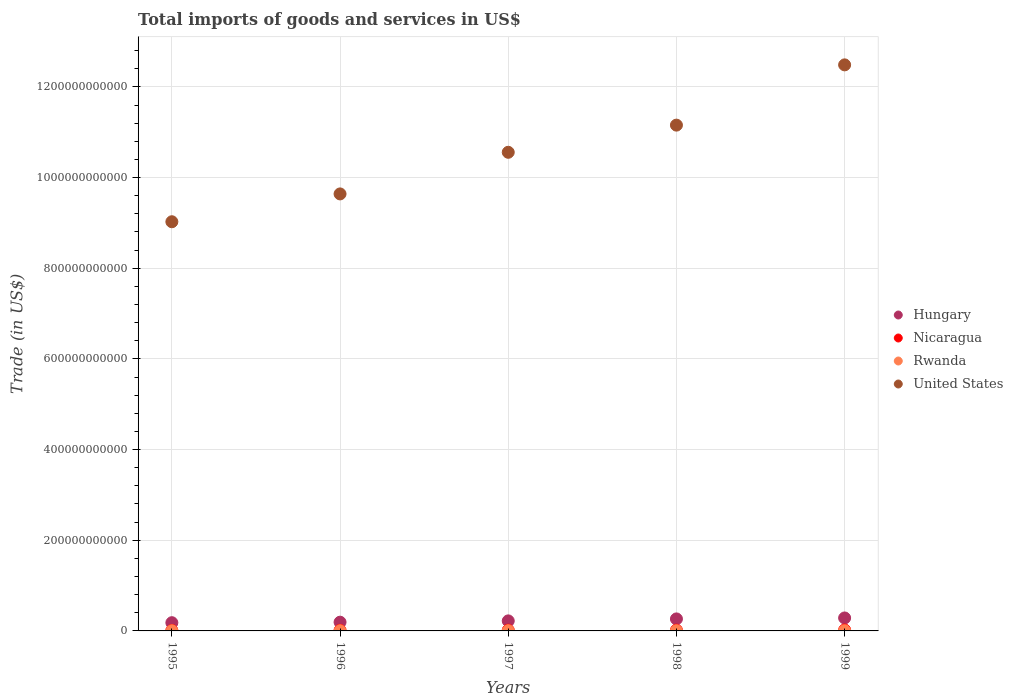How many different coloured dotlines are there?
Provide a short and direct response. 4. Is the number of dotlines equal to the number of legend labels?
Your answer should be very brief. Yes. What is the total imports of goods and services in Rwanda in 1997?
Provide a succinct answer. 4.75e+08. Across all years, what is the maximum total imports of goods and services in Hungary?
Your answer should be compact. 2.86e+1. Across all years, what is the minimum total imports of goods and services in Hungary?
Your answer should be compact. 1.81e+1. In which year was the total imports of goods and services in Nicaragua maximum?
Your answer should be very brief. 1999. What is the total total imports of goods and services in Rwanda in the graph?
Ensure brevity in your answer.  2.08e+09. What is the difference between the total imports of goods and services in United States in 1995 and that in 1998?
Offer a terse response. -2.13e+11. What is the difference between the total imports of goods and services in Nicaragua in 1997 and the total imports of goods and services in United States in 1996?
Offer a terse response. -9.62e+11. What is the average total imports of goods and services in United States per year?
Offer a very short reply. 1.06e+12. In the year 1996, what is the difference between the total imports of goods and services in Nicaragua and total imports of goods and services in Hungary?
Keep it short and to the point. -1.79e+1. In how many years, is the total imports of goods and services in Nicaragua greater than 600000000000 US$?
Offer a very short reply. 0. What is the ratio of the total imports of goods and services in Rwanda in 1996 to that in 1997?
Offer a terse response. 0.76. Is the difference between the total imports of goods and services in Nicaragua in 1998 and 1999 greater than the difference between the total imports of goods and services in Hungary in 1998 and 1999?
Keep it short and to the point. Yes. What is the difference between the highest and the second highest total imports of goods and services in Rwanda?
Provide a short and direct response. 1.36e+07. What is the difference between the highest and the lowest total imports of goods and services in Nicaragua?
Give a very brief answer. 9.80e+08. Is the sum of the total imports of goods and services in United States in 1996 and 1997 greater than the maximum total imports of goods and services in Hungary across all years?
Give a very brief answer. Yes. Is it the case that in every year, the sum of the total imports of goods and services in United States and total imports of goods and services in Rwanda  is greater than the total imports of goods and services in Nicaragua?
Make the answer very short. Yes. Is the total imports of goods and services in Rwanda strictly greater than the total imports of goods and services in Hungary over the years?
Give a very brief answer. No. Is the total imports of goods and services in Rwanda strictly less than the total imports of goods and services in United States over the years?
Give a very brief answer. Yes. How many years are there in the graph?
Offer a terse response. 5. What is the difference between two consecutive major ticks on the Y-axis?
Provide a short and direct response. 2.00e+11. Are the values on the major ticks of Y-axis written in scientific E-notation?
Your response must be concise. No. Does the graph contain grids?
Make the answer very short. Yes. How are the legend labels stacked?
Provide a succinct answer. Vertical. What is the title of the graph?
Your answer should be compact. Total imports of goods and services in US$. Does "Sub-Saharan Africa (all income levels)" appear as one of the legend labels in the graph?
Make the answer very short. No. What is the label or title of the X-axis?
Offer a very short reply. Years. What is the label or title of the Y-axis?
Offer a very short reply. Trade (in US$). What is the Trade (in US$) of Hungary in 1995?
Make the answer very short. 1.81e+1. What is the Trade (in US$) of Nicaragua in 1995?
Your response must be concise. 1.16e+09. What is the Trade (in US$) of Rwanda in 1995?
Offer a very short reply. 3.34e+08. What is the Trade (in US$) of United States in 1995?
Give a very brief answer. 9.03e+11. What is the Trade (in US$) of Hungary in 1996?
Your response must be concise. 1.93e+1. What is the Trade (in US$) in Nicaragua in 1996?
Give a very brief answer. 1.36e+09. What is the Trade (in US$) of Rwanda in 1996?
Provide a short and direct response. 3.62e+08. What is the Trade (in US$) in United States in 1996?
Keep it short and to the point. 9.64e+11. What is the Trade (in US$) of Hungary in 1997?
Ensure brevity in your answer.  2.22e+1. What is the Trade (in US$) of Nicaragua in 1997?
Your answer should be compact. 1.69e+09. What is the Trade (in US$) of Rwanda in 1997?
Offer a very short reply. 4.75e+08. What is the Trade (in US$) of United States in 1997?
Give a very brief answer. 1.06e+12. What is the Trade (in US$) of Hungary in 1998?
Provide a succinct answer. 2.65e+1. What is the Trade (in US$) of Nicaragua in 1998?
Provide a succinct answer. 1.75e+09. What is the Trade (in US$) in Rwanda in 1998?
Make the answer very short. 4.62e+08. What is the Trade (in US$) in United States in 1998?
Keep it short and to the point. 1.12e+12. What is the Trade (in US$) in Hungary in 1999?
Make the answer very short. 2.86e+1. What is the Trade (in US$) of Nicaragua in 1999?
Give a very brief answer. 2.14e+09. What is the Trade (in US$) in Rwanda in 1999?
Your answer should be compact. 4.46e+08. What is the Trade (in US$) of United States in 1999?
Make the answer very short. 1.25e+12. Across all years, what is the maximum Trade (in US$) of Hungary?
Provide a short and direct response. 2.86e+1. Across all years, what is the maximum Trade (in US$) in Nicaragua?
Make the answer very short. 2.14e+09. Across all years, what is the maximum Trade (in US$) of Rwanda?
Offer a very short reply. 4.75e+08. Across all years, what is the maximum Trade (in US$) of United States?
Offer a terse response. 1.25e+12. Across all years, what is the minimum Trade (in US$) of Hungary?
Offer a very short reply. 1.81e+1. Across all years, what is the minimum Trade (in US$) in Nicaragua?
Keep it short and to the point. 1.16e+09. Across all years, what is the minimum Trade (in US$) in Rwanda?
Provide a succinct answer. 3.34e+08. Across all years, what is the minimum Trade (in US$) in United States?
Keep it short and to the point. 9.03e+11. What is the total Trade (in US$) in Hungary in the graph?
Your answer should be compact. 1.15e+11. What is the total Trade (in US$) in Nicaragua in the graph?
Your answer should be very brief. 8.10e+09. What is the total Trade (in US$) of Rwanda in the graph?
Provide a succinct answer. 2.08e+09. What is the total Trade (in US$) in United States in the graph?
Keep it short and to the point. 5.29e+12. What is the difference between the Trade (in US$) of Hungary in 1995 and that in 1996?
Make the answer very short. -1.13e+09. What is the difference between the Trade (in US$) of Nicaragua in 1995 and that in 1996?
Offer a very short reply. -2.06e+08. What is the difference between the Trade (in US$) of Rwanda in 1995 and that in 1996?
Ensure brevity in your answer.  -2.81e+07. What is the difference between the Trade (in US$) of United States in 1995 and that in 1996?
Offer a very short reply. -6.14e+1. What is the difference between the Trade (in US$) of Hungary in 1995 and that in 1997?
Keep it short and to the point. -4.01e+09. What is the difference between the Trade (in US$) of Nicaragua in 1995 and that in 1997?
Your answer should be compact. -5.37e+08. What is the difference between the Trade (in US$) of Rwanda in 1995 and that in 1997?
Provide a short and direct response. -1.41e+08. What is the difference between the Trade (in US$) of United States in 1995 and that in 1997?
Keep it short and to the point. -1.53e+11. What is the difference between the Trade (in US$) of Hungary in 1995 and that in 1998?
Provide a succinct answer. -8.35e+09. What is the difference between the Trade (in US$) of Nicaragua in 1995 and that in 1998?
Provide a succinct answer. -5.89e+08. What is the difference between the Trade (in US$) of Rwanda in 1995 and that in 1998?
Make the answer very short. -1.28e+08. What is the difference between the Trade (in US$) of United States in 1995 and that in 1998?
Offer a very short reply. -2.13e+11. What is the difference between the Trade (in US$) of Hungary in 1995 and that in 1999?
Keep it short and to the point. -1.05e+1. What is the difference between the Trade (in US$) in Nicaragua in 1995 and that in 1999?
Your response must be concise. -9.80e+08. What is the difference between the Trade (in US$) of Rwanda in 1995 and that in 1999?
Ensure brevity in your answer.  -1.12e+08. What is the difference between the Trade (in US$) in United States in 1995 and that in 1999?
Offer a terse response. -3.46e+11. What is the difference between the Trade (in US$) of Hungary in 1996 and that in 1997?
Your response must be concise. -2.88e+09. What is the difference between the Trade (in US$) in Nicaragua in 1996 and that in 1997?
Provide a succinct answer. -3.31e+08. What is the difference between the Trade (in US$) of Rwanda in 1996 and that in 1997?
Provide a short and direct response. -1.13e+08. What is the difference between the Trade (in US$) in United States in 1996 and that in 1997?
Provide a short and direct response. -9.18e+1. What is the difference between the Trade (in US$) of Hungary in 1996 and that in 1998?
Provide a short and direct response. -7.22e+09. What is the difference between the Trade (in US$) in Nicaragua in 1996 and that in 1998?
Give a very brief answer. -3.84e+08. What is the difference between the Trade (in US$) in Rwanda in 1996 and that in 1998?
Provide a succinct answer. -9.96e+07. What is the difference between the Trade (in US$) of United States in 1996 and that in 1998?
Provide a succinct answer. -1.52e+11. What is the difference between the Trade (in US$) of Hungary in 1996 and that in 1999?
Offer a very short reply. -9.33e+09. What is the difference between the Trade (in US$) of Nicaragua in 1996 and that in 1999?
Your response must be concise. -7.74e+08. What is the difference between the Trade (in US$) of Rwanda in 1996 and that in 1999?
Your answer should be very brief. -8.36e+07. What is the difference between the Trade (in US$) in United States in 1996 and that in 1999?
Offer a very short reply. -2.85e+11. What is the difference between the Trade (in US$) in Hungary in 1997 and that in 1998?
Your answer should be compact. -4.34e+09. What is the difference between the Trade (in US$) in Nicaragua in 1997 and that in 1998?
Provide a short and direct response. -5.26e+07. What is the difference between the Trade (in US$) in Rwanda in 1997 and that in 1998?
Your answer should be very brief. 1.36e+07. What is the difference between the Trade (in US$) of United States in 1997 and that in 1998?
Offer a very short reply. -5.99e+1. What is the difference between the Trade (in US$) of Hungary in 1997 and that in 1999?
Provide a succinct answer. -6.45e+09. What is the difference between the Trade (in US$) of Nicaragua in 1997 and that in 1999?
Provide a succinct answer. -4.43e+08. What is the difference between the Trade (in US$) in Rwanda in 1997 and that in 1999?
Your response must be concise. 2.95e+07. What is the difference between the Trade (in US$) of United States in 1997 and that in 1999?
Your answer should be very brief. -1.93e+11. What is the difference between the Trade (in US$) of Hungary in 1998 and that in 1999?
Offer a terse response. -2.11e+09. What is the difference between the Trade (in US$) of Nicaragua in 1998 and that in 1999?
Your answer should be compact. -3.90e+08. What is the difference between the Trade (in US$) of Rwanda in 1998 and that in 1999?
Your answer should be compact. 1.59e+07. What is the difference between the Trade (in US$) in United States in 1998 and that in 1999?
Offer a very short reply. -1.33e+11. What is the difference between the Trade (in US$) of Hungary in 1995 and the Trade (in US$) of Nicaragua in 1996?
Keep it short and to the point. 1.68e+1. What is the difference between the Trade (in US$) of Hungary in 1995 and the Trade (in US$) of Rwanda in 1996?
Your answer should be compact. 1.78e+1. What is the difference between the Trade (in US$) in Hungary in 1995 and the Trade (in US$) in United States in 1996?
Your answer should be very brief. -9.46e+11. What is the difference between the Trade (in US$) of Nicaragua in 1995 and the Trade (in US$) of Rwanda in 1996?
Ensure brevity in your answer.  7.95e+08. What is the difference between the Trade (in US$) of Nicaragua in 1995 and the Trade (in US$) of United States in 1996?
Offer a very short reply. -9.63e+11. What is the difference between the Trade (in US$) in Rwanda in 1995 and the Trade (in US$) in United States in 1996?
Keep it short and to the point. -9.64e+11. What is the difference between the Trade (in US$) of Hungary in 1995 and the Trade (in US$) of Nicaragua in 1997?
Ensure brevity in your answer.  1.64e+1. What is the difference between the Trade (in US$) in Hungary in 1995 and the Trade (in US$) in Rwanda in 1997?
Your response must be concise. 1.77e+1. What is the difference between the Trade (in US$) in Hungary in 1995 and the Trade (in US$) in United States in 1997?
Offer a terse response. -1.04e+12. What is the difference between the Trade (in US$) in Nicaragua in 1995 and the Trade (in US$) in Rwanda in 1997?
Make the answer very short. 6.82e+08. What is the difference between the Trade (in US$) in Nicaragua in 1995 and the Trade (in US$) in United States in 1997?
Offer a very short reply. -1.05e+12. What is the difference between the Trade (in US$) of Rwanda in 1995 and the Trade (in US$) of United States in 1997?
Your answer should be very brief. -1.06e+12. What is the difference between the Trade (in US$) in Hungary in 1995 and the Trade (in US$) in Nicaragua in 1998?
Offer a terse response. 1.64e+1. What is the difference between the Trade (in US$) in Hungary in 1995 and the Trade (in US$) in Rwanda in 1998?
Your answer should be very brief. 1.77e+1. What is the difference between the Trade (in US$) in Hungary in 1995 and the Trade (in US$) in United States in 1998?
Keep it short and to the point. -1.10e+12. What is the difference between the Trade (in US$) in Nicaragua in 1995 and the Trade (in US$) in Rwanda in 1998?
Ensure brevity in your answer.  6.95e+08. What is the difference between the Trade (in US$) in Nicaragua in 1995 and the Trade (in US$) in United States in 1998?
Your response must be concise. -1.11e+12. What is the difference between the Trade (in US$) in Rwanda in 1995 and the Trade (in US$) in United States in 1998?
Your answer should be compact. -1.12e+12. What is the difference between the Trade (in US$) of Hungary in 1995 and the Trade (in US$) of Nicaragua in 1999?
Ensure brevity in your answer.  1.60e+1. What is the difference between the Trade (in US$) of Hungary in 1995 and the Trade (in US$) of Rwanda in 1999?
Offer a very short reply. 1.77e+1. What is the difference between the Trade (in US$) in Hungary in 1995 and the Trade (in US$) in United States in 1999?
Offer a very short reply. -1.23e+12. What is the difference between the Trade (in US$) in Nicaragua in 1995 and the Trade (in US$) in Rwanda in 1999?
Your answer should be very brief. 7.11e+08. What is the difference between the Trade (in US$) in Nicaragua in 1995 and the Trade (in US$) in United States in 1999?
Your response must be concise. -1.25e+12. What is the difference between the Trade (in US$) in Rwanda in 1995 and the Trade (in US$) in United States in 1999?
Give a very brief answer. -1.25e+12. What is the difference between the Trade (in US$) of Hungary in 1996 and the Trade (in US$) of Nicaragua in 1997?
Keep it short and to the point. 1.76e+1. What is the difference between the Trade (in US$) in Hungary in 1996 and the Trade (in US$) in Rwanda in 1997?
Your response must be concise. 1.88e+1. What is the difference between the Trade (in US$) in Hungary in 1996 and the Trade (in US$) in United States in 1997?
Your response must be concise. -1.04e+12. What is the difference between the Trade (in US$) in Nicaragua in 1996 and the Trade (in US$) in Rwanda in 1997?
Keep it short and to the point. 8.88e+08. What is the difference between the Trade (in US$) in Nicaragua in 1996 and the Trade (in US$) in United States in 1997?
Make the answer very short. -1.05e+12. What is the difference between the Trade (in US$) in Rwanda in 1996 and the Trade (in US$) in United States in 1997?
Offer a very short reply. -1.06e+12. What is the difference between the Trade (in US$) of Hungary in 1996 and the Trade (in US$) of Nicaragua in 1998?
Ensure brevity in your answer.  1.75e+1. What is the difference between the Trade (in US$) in Hungary in 1996 and the Trade (in US$) in Rwanda in 1998?
Offer a very short reply. 1.88e+1. What is the difference between the Trade (in US$) in Hungary in 1996 and the Trade (in US$) in United States in 1998?
Provide a short and direct response. -1.10e+12. What is the difference between the Trade (in US$) of Nicaragua in 1996 and the Trade (in US$) of Rwanda in 1998?
Offer a very short reply. 9.01e+08. What is the difference between the Trade (in US$) in Nicaragua in 1996 and the Trade (in US$) in United States in 1998?
Provide a succinct answer. -1.11e+12. What is the difference between the Trade (in US$) of Rwanda in 1996 and the Trade (in US$) of United States in 1998?
Offer a very short reply. -1.12e+12. What is the difference between the Trade (in US$) of Hungary in 1996 and the Trade (in US$) of Nicaragua in 1999?
Your answer should be very brief. 1.71e+1. What is the difference between the Trade (in US$) of Hungary in 1996 and the Trade (in US$) of Rwanda in 1999?
Provide a short and direct response. 1.88e+1. What is the difference between the Trade (in US$) of Hungary in 1996 and the Trade (in US$) of United States in 1999?
Give a very brief answer. -1.23e+12. What is the difference between the Trade (in US$) in Nicaragua in 1996 and the Trade (in US$) in Rwanda in 1999?
Make the answer very short. 9.17e+08. What is the difference between the Trade (in US$) in Nicaragua in 1996 and the Trade (in US$) in United States in 1999?
Offer a terse response. -1.25e+12. What is the difference between the Trade (in US$) in Rwanda in 1996 and the Trade (in US$) in United States in 1999?
Offer a very short reply. -1.25e+12. What is the difference between the Trade (in US$) of Hungary in 1997 and the Trade (in US$) of Nicaragua in 1998?
Provide a short and direct response. 2.04e+1. What is the difference between the Trade (in US$) of Hungary in 1997 and the Trade (in US$) of Rwanda in 1998?
Keep it short and to the point. 2.17e+1. What is the difference between the Trade (in US$) in Hungary in 1997 and the Trade (in US$) in United States in 1998?
Make the answer very short. -1.09e+12. What is the difference between the Trade (in US$) of Nicaragua in 1997 and the Trade (in US$) of Rwanda in 1998?
Your answer should be very brief. 1.23e+09. What is the difference between the Trade (in US$) of Nicaragua in 1997 and the Trade (in US$) of United States in 1998?
Offer a very short reply. -1.11e+12. What is the difference between the Trade (in US$) of Rwanda in 1997 and the Trade (in US$) of United States in 1998?
Make the answer very short. -1.12e+12. What is the difference between the Trade (in US$) of Hungary in 1997 and the Trade (in US$) of Nicaragua in 1999?
Your answer should be very brief. 2.00e+1. What is the difference between the Trade (in US$) of Hungary in 1997 and the Trade (in US$) of Rwanda in 1999?
Keep it short and to the point. 2.17e+1. What is the difference between the Trade (in US$) of Hungary in 1997 and the Trade (in US$) of United States in 1999?
Provide a short and direct response. -1.23e+12. What is the difference between the Trade (in US$) in Nicaragua in 1997 and the Trade (in US$) in Rwanda in 1999?
Your answer should be very brief. 1.25e+09. What is the difference between the Trade (in US$) of Nicaragua in 1997 and the Trade (in US$) of United States in 1999?
Give a very brief answer. -1.25e+12. What is the difference between the Trade (in US$) in Rwanda in 1997 and the Trade (in US$) in United States in 1999?
Give a very brief answer. -1.25e+12. What is the difference between the Trade (in US$) of Hungary in 1998 and the Trade (in US$) of Nicaragua in 1999?
Your response must be concise. 2.44e+1. What is the difference between the Trade (in US$) in Hungary in 1998 and the Trade (in US$) in Rwanda in 1999?
Provide a short and direct response. 2.60e+1. What is the difference between the Trade (in US$) of Hungary in 1998 and the Trade (in US$) of United States in 1999?
Ensure brevity in your answer.  -1.22e+12. What is the difference between the Trade (in US$) of Nicaragua in 1998 and the Trade (in US$) of Rwanda in 1999?
Your response must be concise. 1.30e+09. What is the difference between the Trade (in US$) in Nicaragua in 1998 and the Trade (in US$) in United States in 1999?
Make the answer very short. -1.25e+12. What is the difference between the Trade (in US$) in Rwanda in 1998 and the Trade (in US$) in United States in 1999?
Offer a terse response. -1.25e+12. What is the average Trade (in US$) of Hungary per year?
Provide a short and direct response. 2.29e+1. What is the average Trade (in US$) of Nicaragua per year?
Keep it short and to the point. 1.62e+09. What is the average Trade (in US$) in Rwanda per year?
Your answer should be very brief. 4.16e+08. What is the average Trade (in US$) of United States per year?
Give a very brief answer. 1.06e+12. In the year 1995, what is the difference between the Trade (in US$) in Hungary and Trade (in US$) in Nicaragua?
Offer a terse response. 1.70e+1. In the year 1995, what is the difference between the Trade (in US$) in Hungary and Trade (in US$) in Rwanda?
Provide a short and direct response. 1.78e+1. In the year 1995, what is the difference between the Trade (in US$) in Hungary and Trade (in US$) in United States?
Keep it short and to the point. -8.84e+11. In the year 1995, what is the difference between the Trade (in US$) in Nicaragua and Trade (in US$) in Rwanda?
Offer a very short reply. 8.23e+08. In the year 1995, what is the difference between the Trade (in US$) of Nicaragua and Trade (in US$) of United States?
Offer a very short reply. -9.01e+11. In the year 1995, what is the difference between the Trade (in US$) in Rwanda and Trade (in US$) in United States?
Make the answer very short. -9.02e+11. In the year 1996, what is the difference between the Trade (in US$) in Hungary and Trade (in US$) in Nicaragua?
Provide a succinct answer. 1.79e+1. In the year 1996, what is the difference between the Trade (in US$) in Hungary and Trade (in US$) in Rwanda?
Provide a short and direct response. 1.89e+1. In the year 1996, what is the difference between the Trade (in US$) in Hungary and Trade (in US$) in United States?
Give a very brief answer. -9.45e+11. In the year 1996, what is the difference between the Trade (in US$) in Nicaragua and Trade (in US$) in Rwanda?
Ensure brevity in your answer.  1.00e+09. In the year 1996, what is the difference between the Trade (in US$) of Nicaragua and Trade (in US$) of United States?
Ensure brevity in your answer.  -9.63e+11. In the year 1996, what is the difference between the Trade (in US$) in Rwanda and Trade (in US$) in United States?
Provide a short and direct response. -9.64e+11. In the year 1997, what is the difference between the Trade (in US$) in Hungary and Trade (in US$) in Nicaragua?
Ensure brevity in your answer.  2.05e+1. In the year 1997, what is the difference between the Trade (in US$) in Hungary and Trade (in US$) in Rwanda?
Your answer should be compact. 2.17e+1. In the year 1997, what is the difference between the Trade (in US$) in Hungary and Trade (in US$) in United States?
Offer a terse response. -1.03e+12. In the year 1997, what is the difference between the Trade (in US$) in Nicaragua and Trade (in US$) in Rwanda?
Your answer should be compact. 1.22e+09. In the year 1997, what is the difference between the Trade (in US$) of Nicaragua and Trade (in US$) of United States?
Offer a very short reply. -1.05e+12. In the year 1997, what is the difference between the Trade (in US$) of Rwanda and Trade (in US$) of United States?
Your response must be concise. -1.06e+12. In the year 1998, what is the difference between the Trade (in US$) in Hungary and Trade (in US$) in Nicaragua?
Your answer should be compact. 2.47e+1. In the year 1998, what is the difference between the Trade (in US$) of Hungary and Trade (in US$) of Rwanda?
Your response must be concise. 2.60e+1. In the year 1998, what is the difference between the Trade (in US$) of Hungary and Trade (in US$) of United States?
Your answer should be compact. -1.09e+12. In the year 1998, what is the difference between the Trade (in US$) of Nicaragua and Trade (in US$) of Rwanda?
Your answer should be compact. 1.28e+09. In the year 1998, what is the difference between the Trade (in US$) in Nicaragua and Trade (in US$) in United States?
Your answer should be compact. -1.11e+12. In the year 1998, what is the difference between the Trade (in US$) in Rwanda and Trade (in US$) in United States?
Offer a terse response. -1.12e+12. In the year 1999, what is the difference between the Trade (in US$) in Hungary and Trade (in US$) in Nicaragua?
Keep it short and to the point. 2.65e+1. In the year 1999, what is the difference between the Trade (in US$) in Hungary and Trade (in US$) in Rwanda?
Ensure brevity in your answer.  2.82e+1. In the year 1999, what is the difference between the Trade (in US$) of Hungary and Trade (in US$) of United States?
Provide a short and direct response. -1.22e+12. In the year 1999, what is the difference between the Trade (in US$) of Nicaragua and Trade (in US$) of Rwanda?
Provide a short and direct response. 1.69e+09. In the year 1999, what is the difference between the Trade (in US$) of Nicaragua and Trade (in US$) of United States?
Ensure brevity in your answer.  -1.25e+12. In the year 1999, what is the difference between the Trade (in US$) of Rwanda and Trade (in US$) of United States?
Ensure brevity in your answer.  -1.25e+12. What is the ratio of the Trade (in US$) in Hungary in 1995 to that in 1996?
Offer a very short reply. 0.94. What is the ratio of the Trade (in US$) in Nicaragua in 1995 to that in 1996?
Offer a terse response. 0.85. What is the ratio of the Trade (in US$) of Rwanda in 1995 to that in 1996?
Make the answer very short. 0.92. What is the ratio of the Trade (in US$) of United States in 1995 to that in 1996?
Your response must be concise. 0.94. What is the ratio of the Trade (in US$) of Hungary in 1995 to that in 1997?
Make the answer very short. 0.82. What is the ratio of the Trade (in US$) in Nicaragua in 1995 to that in 1997?
Offer a very short reply. 0.68. What is the ratio of the Trade (in US$) of Rwanda in 1995 to that in 1997?
Ensure brevity in your answer.  0.7. What is the ratio of the Trade (in US$) of United States in 1995 to that in 1997?
Offer a terse response. 0.85. What is the ratio of the Trade (in US$) in Hungary in 1995 to that in 1998?
Make the answer very short. 0.68. What is the ratio of the Trade (in US$) in Nicaragua in 1995 to that in 1998?
Provide a succinct answer. 0.66. What is the ratio of the Trade (in US$) of Rwanda in 1995 to that in 1998?
Ensure brevity in your answer.  0.72. What is the ratio of the Trade (in US$) in United States in 1995 to that in 1998?
Keep it short and to the point. 0.81. What is the ratio of the Trade (in US$) of Hungary in 1995 to that in 1999?
Your answer should be compact. 0.63. What is the ratio of the Trade (in US$) in Nicaragua in 1995 to that in 1999?
Your answer should be very brief. 0.54. What is the ratio of the Trade (in US$) in Rwanda in 1995 to that in 1999?
Make the answer very short. 0.75. What is the ratio of the Trade (in US$) of United States in 1995 to that in 1999?
Provide a succinct answer. 0.72. What is the ratio of the Trade (in US$) of Hungary in 1996 to that in 1997?
Your response must be concise. 0.87. What is the ratio of the Trade (in US$) of Nicaragua in 1996 to that in 1997?
Your answer should be compact. 0.8. What is the ratio of the Trade (in US$) of Rwanda in 1996 to that in 1997?
Provide a short and direct response. 0.76. What is the ratio of the Trade (in US$) in United States in 1996 to that in 1997?
Keep it short and to the point. 0.91. What is the ratio of the Trade (in US$) of Hungary in 1996 to that in 1998?
Your answer should be very brief. 0.73. What is the ratio of the Trade (in US$) in Nicaragua in 1996 to that in 1998?
Your answer should be compact. 0.78. What is the ratio of the Trade (in US$) of Rwanda in 1996 to that in 1998?
Your response must be concise. 0.78. What is the ratio of the Trade (in US$) of United States in 1996 to that in 1998?
Give a very brief answer. 0.86. What is the ratio of the Trade (in US$) of Hungary in 1996 to that in 1999?
Your response must be concise. 0.67. What is the ratio of the Trade (in US$) of Nicaragua in 1996 to that in 1999?
Keep it short and to the point. 0.64. What is the ratio of the Trade (in US$) of Rwanda in 1996 to that in 1999?
Give a very brief answer. 0.81. What is the ratio of the Trade (in US$) in United States in 1996 to that in 1999?
Your response must be concise. 0.77. What is the ratio of the Trade (in US$) in Hungary in 1997 to that in 1998?
Provide a short and direct response. 0.84. What is the ratio of the Trade (in US$) of Nicaragua in 1997 to that in 1998?
Your answer should be compact. 0.97. What is the ratio of the Trade (in US$) of Rwanda in 1997 to that in 1998?
Make the answer very short. 1.03. What is the ratio of the Trade (in US$) in United States in 1997 to that in 1998?
Provide a short and direct response. 0.95. What is the ratio of the Trade (in US$) in Hungary in 1997 to that in 1999?
Give a very brief answer. 0.77. What is the ratio of the Trade (in US$) of Nicaragua in 1997 to that in 1999?
Your answer should be compact. 0.79. What is the ratio of the Trade (in US$) in Rwanda in 1997 to that in 1999?
Provide a succinct answer. 1.07. What is the ratio of the Trade (in US$) of United States in 1997 to that in 1999?
Ensure brevity in your answer.  0.85. What is the ratio of the Trade (in US$) in Hungary in 1998 to that in 1999?
Keep it short and to the point. 0.93. What is the ratio of the Trade (in US$) of Nicaragua in 1998 to that in 1999?
Make the answer very short. 0.82. What is the ratio of the Trade (in US$) in Rwanda in 1998 to that in 1999?
Provide a succinct answer. 1.04. What is the ratio of the Trade (in US$) of United States in 1998 to that in 1999?
Your response must be concise. 0.89. What is the difference between the highest and the second highest Trade (in US$) of Hungary?
Offer a very short reply. 2.11e+09. What is the difference between the highest and the second highest Trade (in US$) of Nicaragua?
Your response must be concise. 3.90e+08. What is the difference between the highest and the second highest Trade (in US$) of Rwanda?
Keep it short and to the point. 1.36e+07. What is the difference between the highest and the second highest Trade (in US$) in United States?
Your answer should be very brief. 1.33e+11. What is the difference between the highest and the lowest Trade (in US$) of Hungary?
Your response must be concise. 1.05e+1. What is the difference between the highest and the lowest Trade (in US$) in Nicaragua?
Make the answer very short. 9.80e+08. What is the difference between the highest and the lowest Trade (in US$) of Rwanda?
Your response must be concise. 1.41e+08. What is the difference between the highest and the lowest Trade (in US$) in United States?
Ensure brevity in your answer.  3.46e+11. 